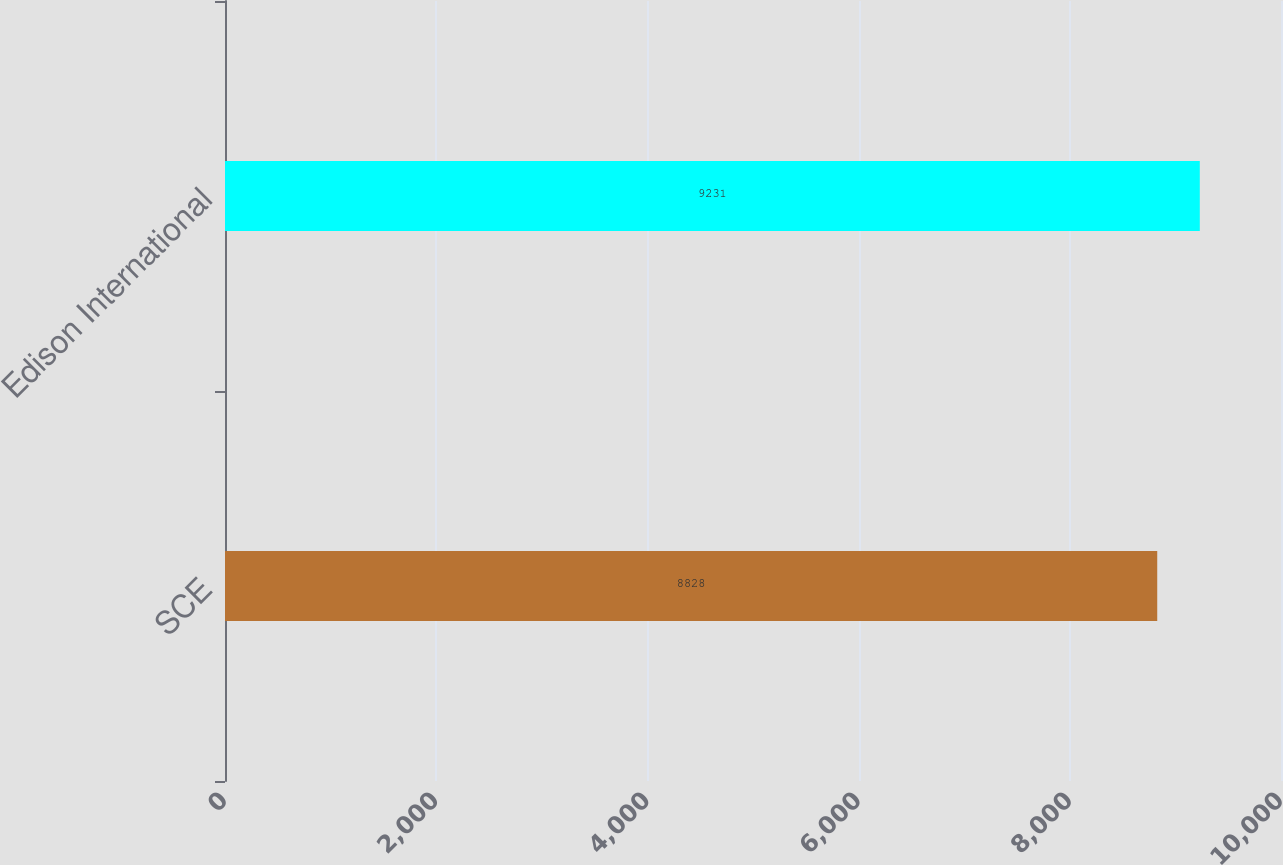Convert chart to OTSL. <chart><loc_0><loc_0><loc_500><loc_500><bar_chart><fcel>SCE<fcel>Edison International<nl><fcel>8828<fcel>9231<nl></chart> 